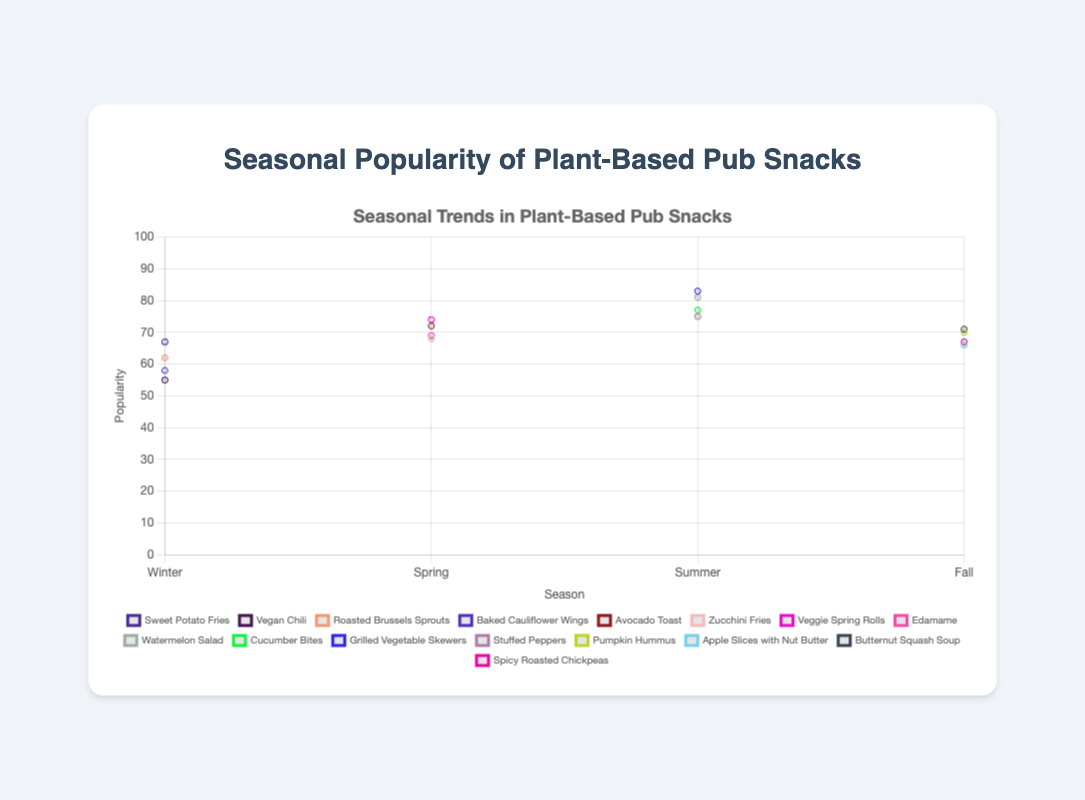What's the most popular plant-based snack in the summer season? Look for the highest popularity value among the summer plant-based snacks. The snacks include Watermelon Salad (81), Cucumber Bites (77), Grilled Vegetable Skewers (83), and Stuffed Peppers (75). The highest is for Grilled Vegetable Skewers.
Answer: Grilled Vegetable Skewers How does the popularity of Avocado Toast in the spring compare to the popularity of Pumpkin Hummus in the fall? Avocado Toast has a popularity of 72 in the spring, and Pumpkin Hummus has a popularity of 70 in the fall. Comparing these two values, Avocado Toast is slightly more popular.
Answer: Avocado Toast is more popular Which season has the least variation in the popularity of its snacks? Calculate the range (difference between the highest and lowest values) for the popularity of snacks in each season. Winter range is (67-55)=12, Spring range is (74-68)=6, Summer range is (83-75)=8, Fall range is (71-66)=5. The smallest range indicates the least variation.
Answer: Fall What's the sum of the popularity scores of the snacks in the winter season? Add the popularity scores of all snacks in winter: Sweet Potato Fries (67), Vegan Chili (55), Roasted Brussels Sprouts (62), and Baked Cauliflower Wings (58). The sum is 67 + 55 + 62 + 58.
Answer: 242 Which snack has the highest popularity across all seasons? Compare the highest popularity values in each season to find the overall highest: Winter (67), Spring (74), Summer (83), Fall (71). The snack with the highest overall popularity score is from the summer season, specifically Grilled Vegetable Skewers with 83 points.
Answer: Grilled Vegetable Skewers How does the average popularity of snacks in winter compare to summer? First, calculate the average popularity for each season. Winter: (67+55+62+58)/4=60.5, Summer: (81+77+83+75)/4=79. Then compare these averages.
Answer: Summer has a higher average What is the most significant increase in popularity from one season to the next for a single snack? Compare the popularity of each snack across two seasons and find the maximum increase. For example, Avocado Toast (Spring) to (no similar snack in Winter)=NA, Sweet Potato Fries (Winter) to (no similar snack in Spring)=NA, etc. Identify the largest increase. The largest increase is for Grilled Vegetable Skewers from Winter (not present, i.e. 0) to Summer (83).
Answer: Grilled Vegetable Skewers Which snack's popularity increased the most from winter to spring? Compare popularity values of snacks available in both winter and spring. Identify which one has the highest positive difference: Avocado Toast (not available in Winter), Vegan Chili (not available in Spring), Roasted Brussels Sprouts (not available in Spring), Baked Cauliflower Wings (not available in Spring). No snack is common in these seasons, therefore no specific pair for comparison.
Answer: No common snack 